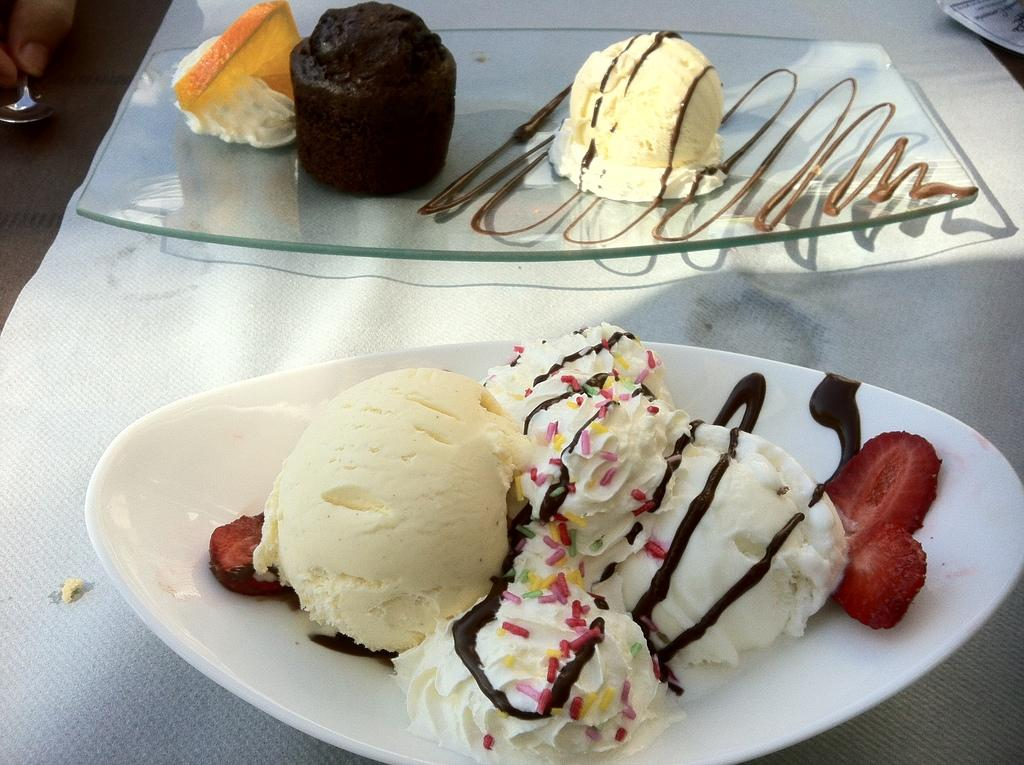What type of food items can be seen in the image? There are ice creams and other food items in the image. How are the ice creams and food items arranged in the image? The ice creams and food items are on a glass plate in the image. What color is the object visible in the image? There is a white color object in the image. On what surface are the objects placed in the image? The objects are on a surface in the image. How many frogs are present in the image? There are no frogs present in the image. What type of regret can be seen on the faces of the people in the image? There are no people or expressions of regret visible in the image. 